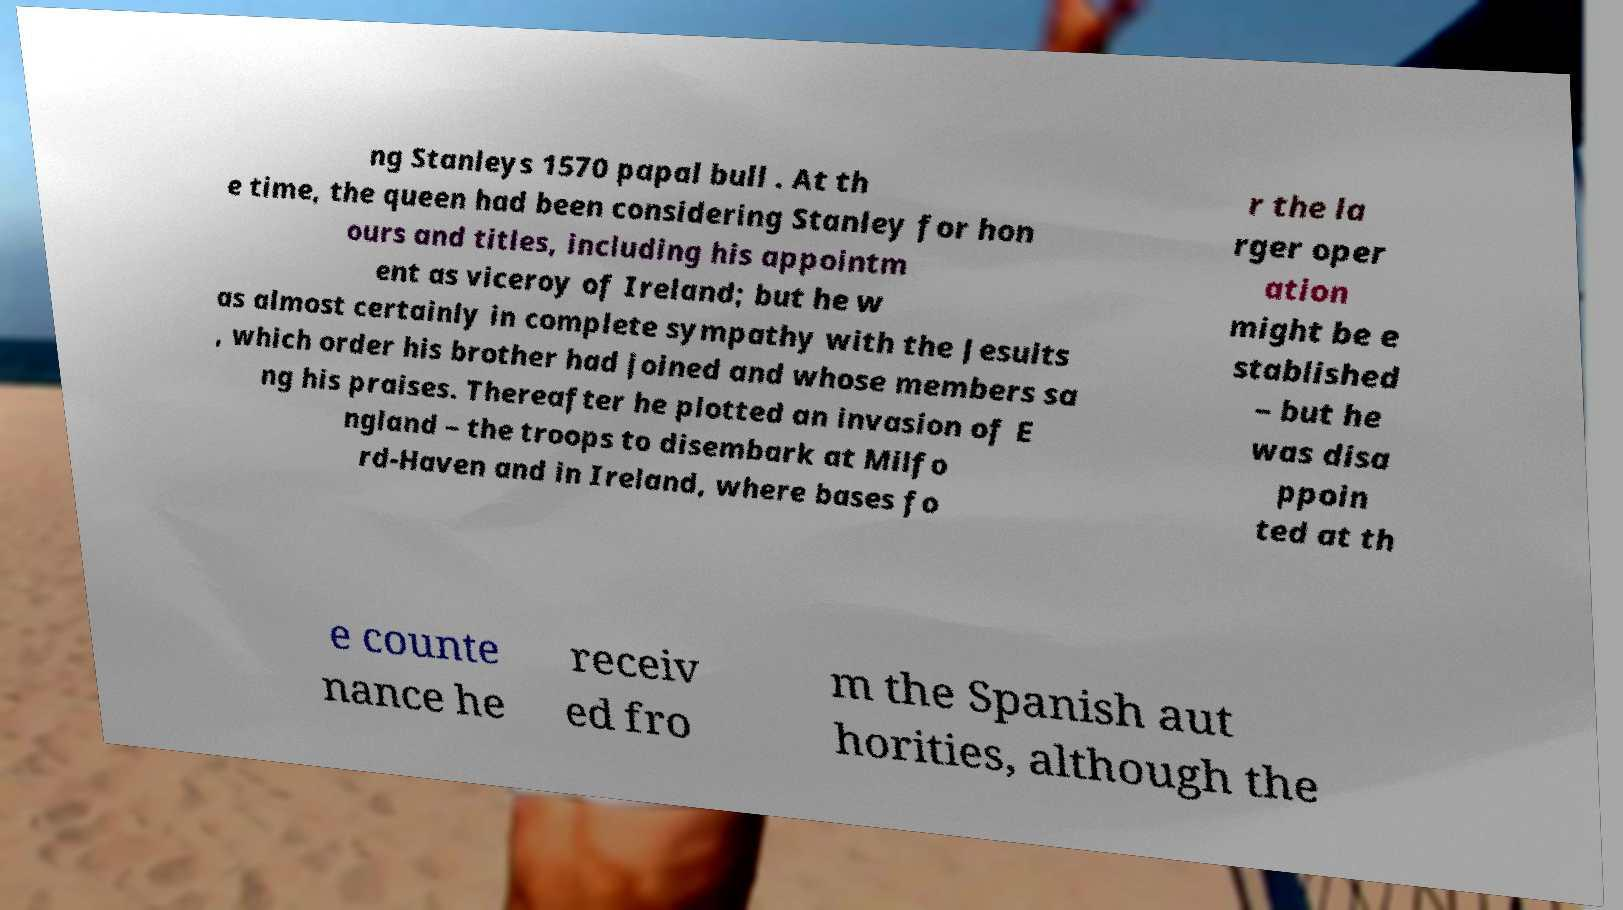Could you extract and type out the text from this image? ng Stanleys 1570 papal bull . At th e time, the queen had been considering Stanley for hon ours and titles, including his appointm ent as viceroy of Ireland; but he w as almost certainly in complete sympathy with the Jesuits , which order his brother had joined and whose members sa ng his praises. Thereafter he plotted an invasion of E ngland – the troops to disembark at Milfo rd-Haven and in Ireland, where bases fo r the la rger oper ation might be e stablished – but he was disa ppoin ted at th e counte nance he receiv ed fro m the Spanish aut horities, although the 